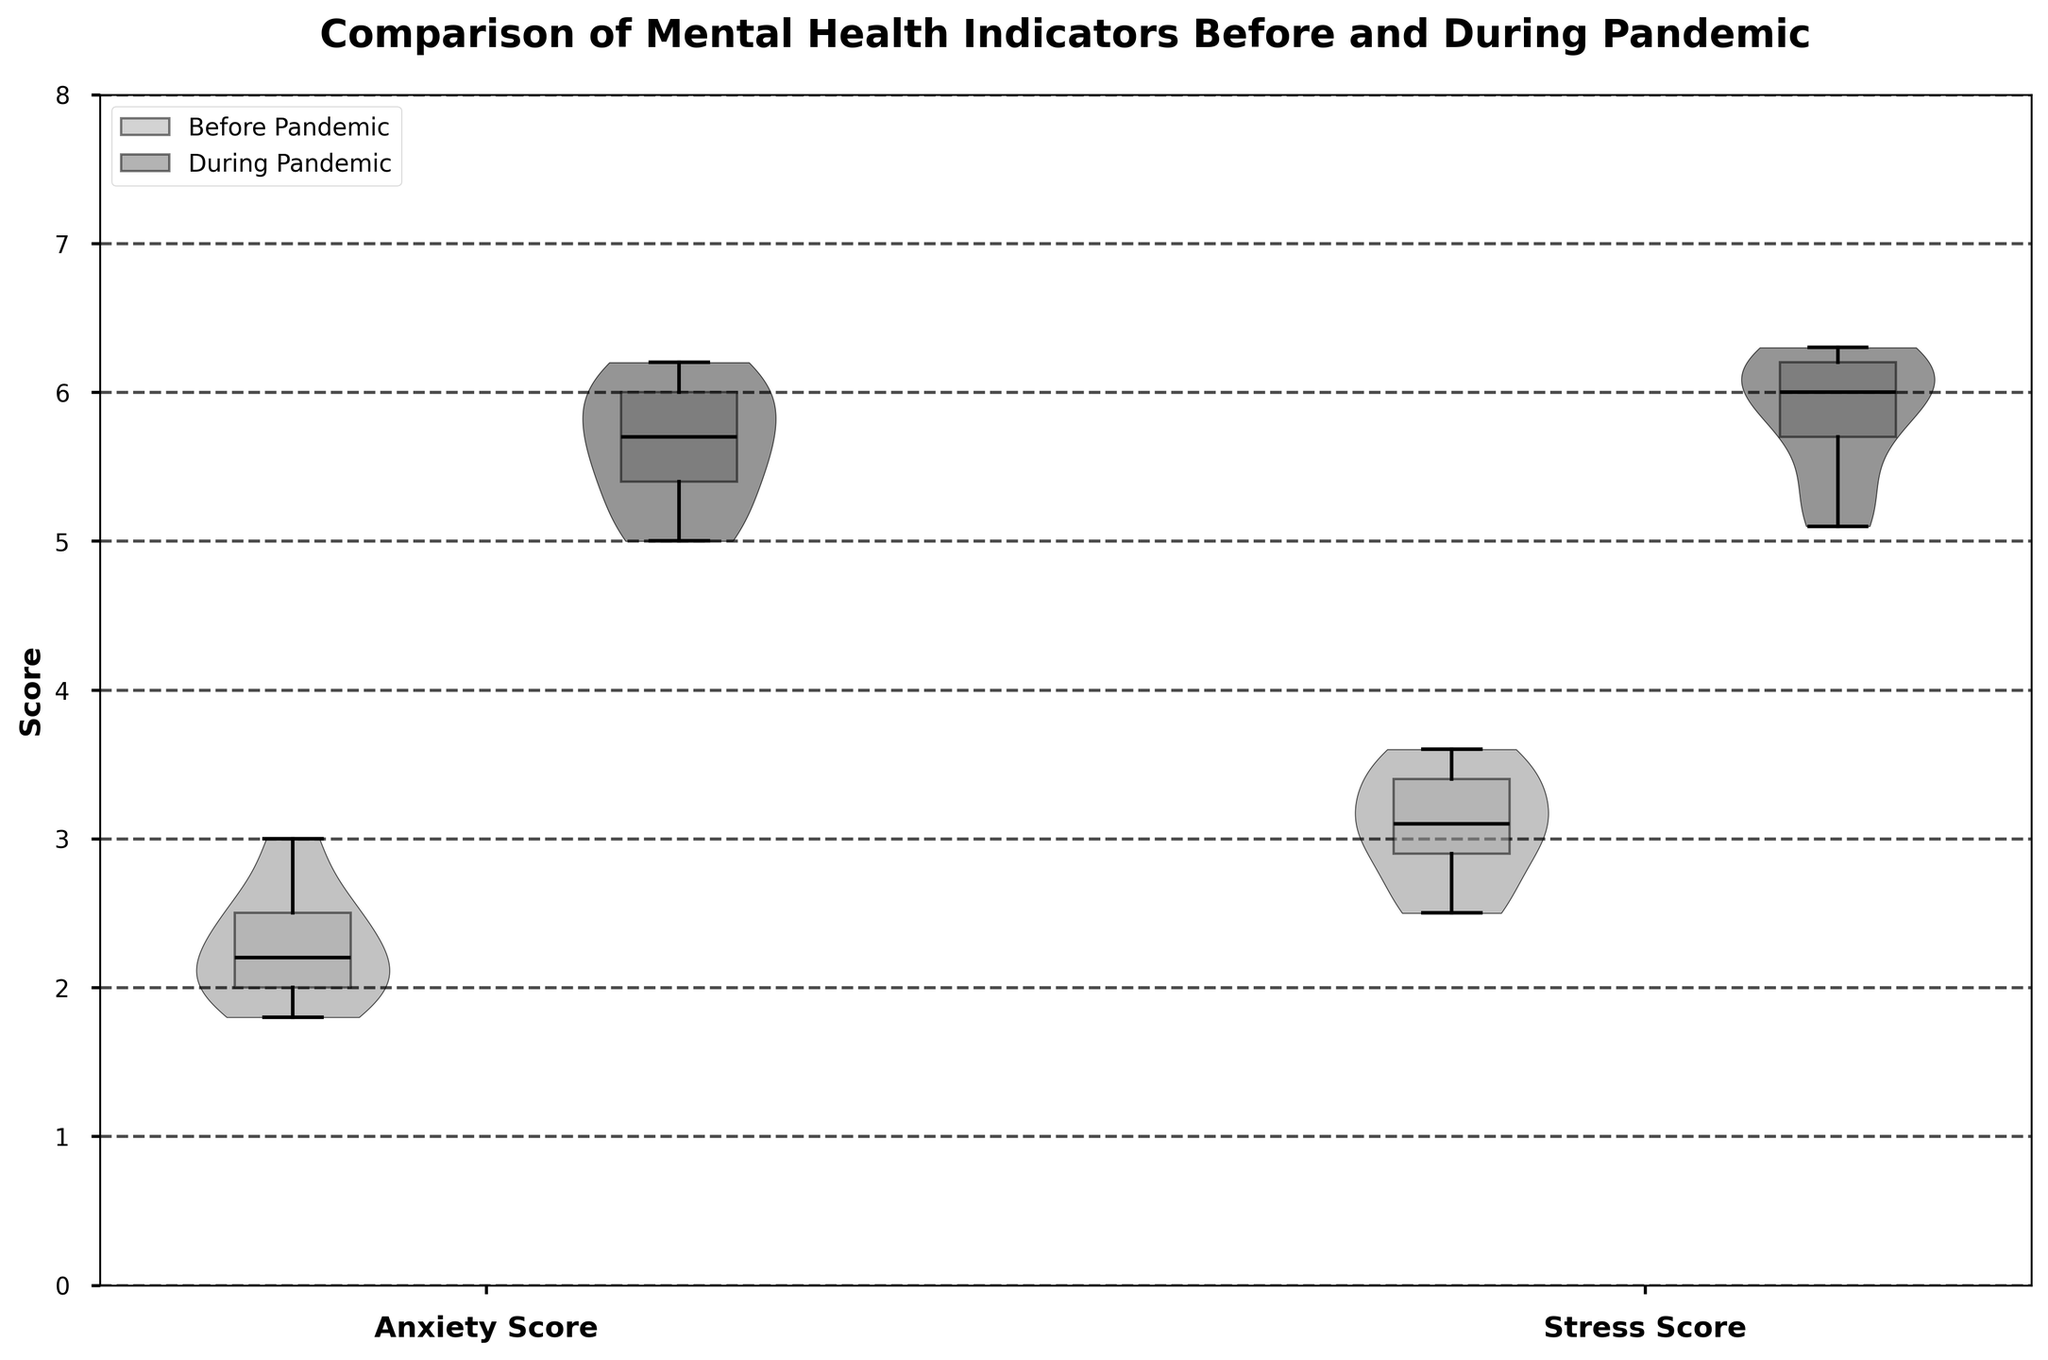What are the two mental health indicators compared in the chart? The chart title "Comparison of Mental Health Indicators Before and During Pandemic" and axis labels indicate that the mental health indicators compared are "Anxiety Score" and "Stress Score".
Answer: Anxiety and Stress Which time periods are shown for each mental health indicator? The legend indicates "Before Pandemic" and "During Pandemic". These two time periods provide the context for comparison.
Answer: Before Pandemic and During Pandemic What is the range of Anxiety Scores during the pandemic? Looking at the violin plot and the corresponding box plot for Anxiety Scores during the pandemic, the range appears to be from approximately 5 to 7.
Answer: 5 to 7 Which indicator shows a higher median value during the pandemic? Observing the median lines in the box plots, both Anxiety and Stress Scores during the pandemic appear to have high median values, but Stress Score shows slightly higher.
Answer: Stress Score How do Anxiety Scores before and during the pandemic compare? The violin plots show that Anxiety Scores increased significantly during the pandemic, evident by a shift in the entire distribution upwards. The boxplot median lines also support this with higher medians during the pandemic.
Answer: Increased What is the upper quartile value for Stress Scores before the pandemic? By examining the box plot for Stress Scores before the pandemic, the line at the top of the box represents the upper quartile, which looks to be approximately 4.2.
Answer: 4.2 Is the range of Stress Scores wider or narrower than Anxiety Scores before the pandemic? The width of the violins and the length of the boxplots indicate range. Stress Scores show a narrower distribution compared to Anxiety Scores before the pandemic.
Answer: Narrower What is the median Anxiety Score before the pandemic? The line within the box of the boxplot for Anxiety Scores before the pandemic indicates the median, approximately around 2.2.
Answer: 2.2 Which educational center showed the most significant increase in stress during the pandemic? The provided data indicates stress levels in various centers increased, but if determining visually from the range shift in violins and outliers isn't distinctible, refer back to the provided dataset.
Answer: Cannot determine visually What does the spread of the violin plot indicate about data distribution? Violin plots show the density of data points at different values. A wider section means more data points. The violins during the pandemic are higher and wider, indicating more children had elevated scores.
Answer: Higher density during pandemic 